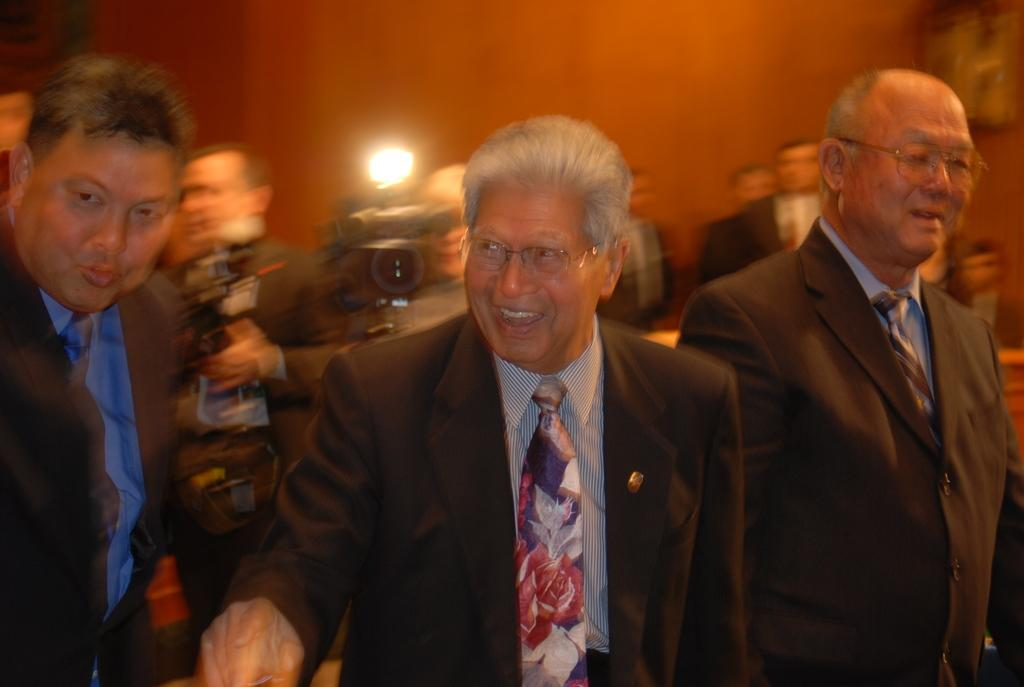How many people are in the image? There are three people in the image. What are the people doing in the image? The people are standing and smiling. What can be seen in the background of the image? There are camera flashes in the background of the image. What type of coil is being used by the people in the image? There is no coil present in the image; the people are simply standing and smiling. 